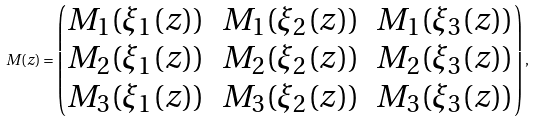Convert formula to latex. <formula><loc_0><loc_0><loc_500><loc_500>M ( z ) = \begin{pmatrix} M _ { 1 } ( \xi _ { 1 } ( z ) ) & M _ { 1 } ( \xi _ { 2 } ( z ) ) & M _ { 1 } ( \xi _ { 3 } ( z ) ) \\ M _ { 2 } ( \xi _ { 1 } ( z ) ) & M _ { 2 } ( \xi _ { 2 } ( z ) ) & M _ { 2 } ( \xi _ { 3 } ( z ) ) \\ M _ { 3 } ( \xi _ { 1 } ( z ) ) & M _ { 3 } ( \xi _ { 2 } ( z ) ) & M _ { 3 } ( \xi _ { 3 } ( z ) ) \end{pmatrix} ,</formula> 